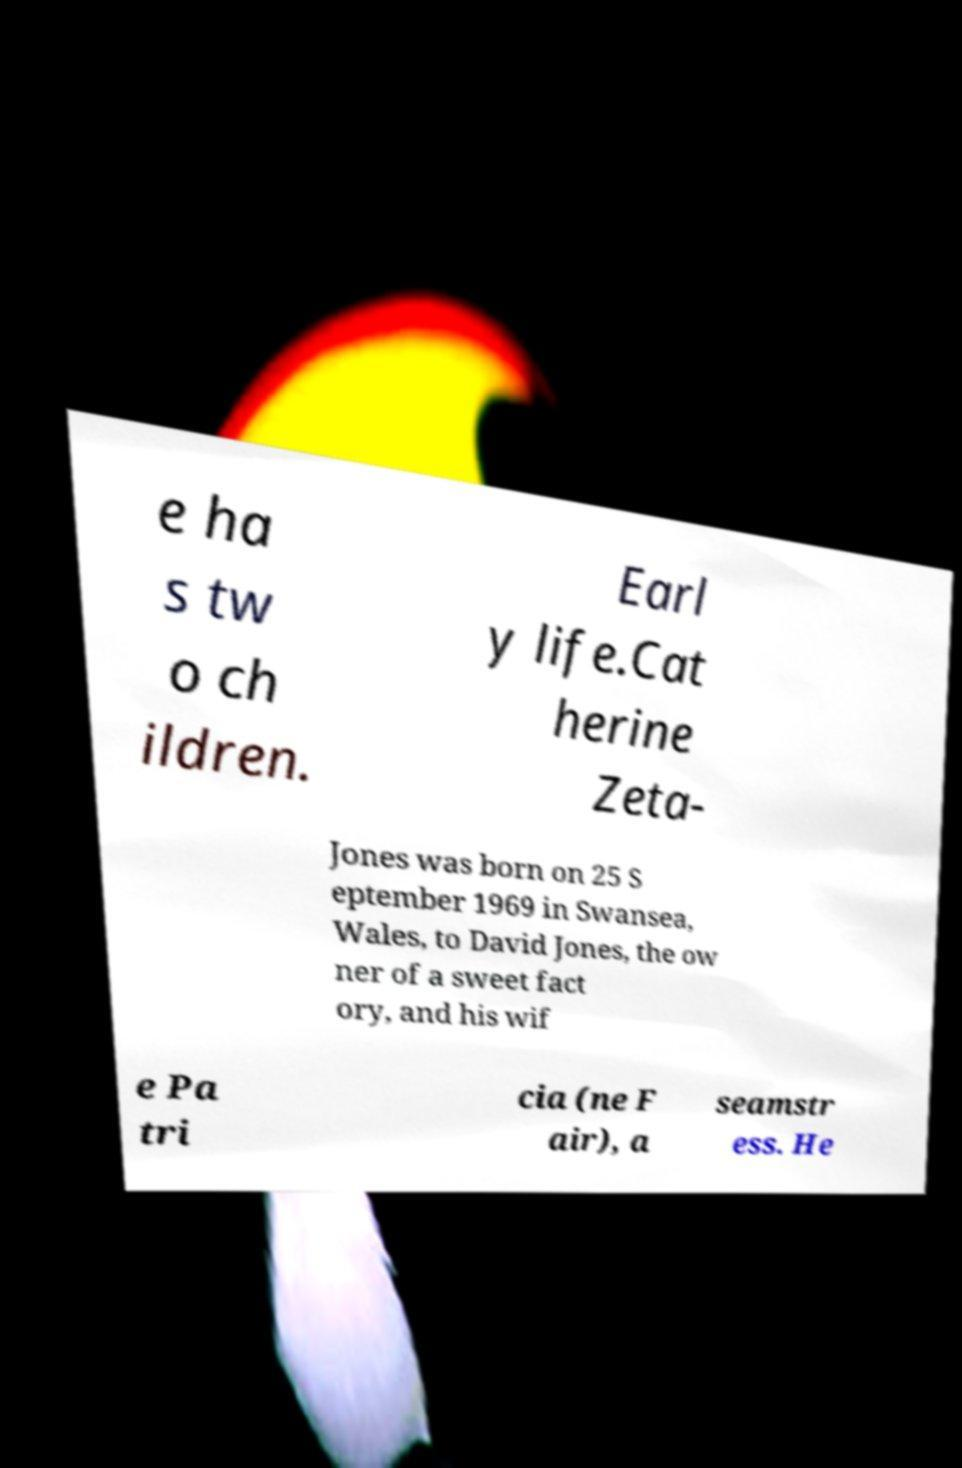What messages or text are displayed in this image? I need them in a readable, typed format. e ha s tw o ch ildren. Earl y life.Cat herine Zeta- Jones was born on 25 S eptember 1969 in Swansea, Wales, to David Jones, the ow ner of a sweet fact ory, and his wif e Pa tri cia (ne F air), a seamstr ess. He 